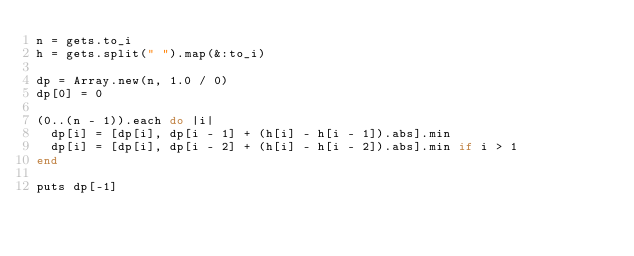<code> <loc_0><loc_0><loc_500><loc_500><_Ruby_>n = gets.to_i
h = gets.split(" ").map(&:to_i)

dp = Array.new(n, 1.0 / 0)
dp[0] = 0

(0..(n - 1)).each do |i|
  dp[i] = [dp[i], dp[i - 1] + (h[i] - h[i - 1]).abs].min
  dp[i] = [dp[i], dp[i - 2] + (h[i] - h[i - 2]).abs].min if i > 1
end

puts dp[-1]</code> 